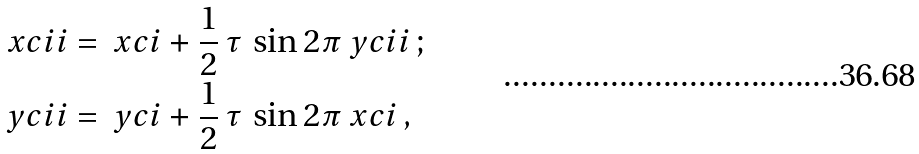<formula> <loc_0><loc_0><loc_500><loc_500>\ x c i i & = \ x c i + \frac { 1 } { 2 } \, \tau \, \sin 2 \pi \ y c i i \, ; \\ \ y c i i & = \ y c i + \frac { 1 } { 2 } \, \tau \, \sin 2 \pi \ x c i \, ,</formula> 